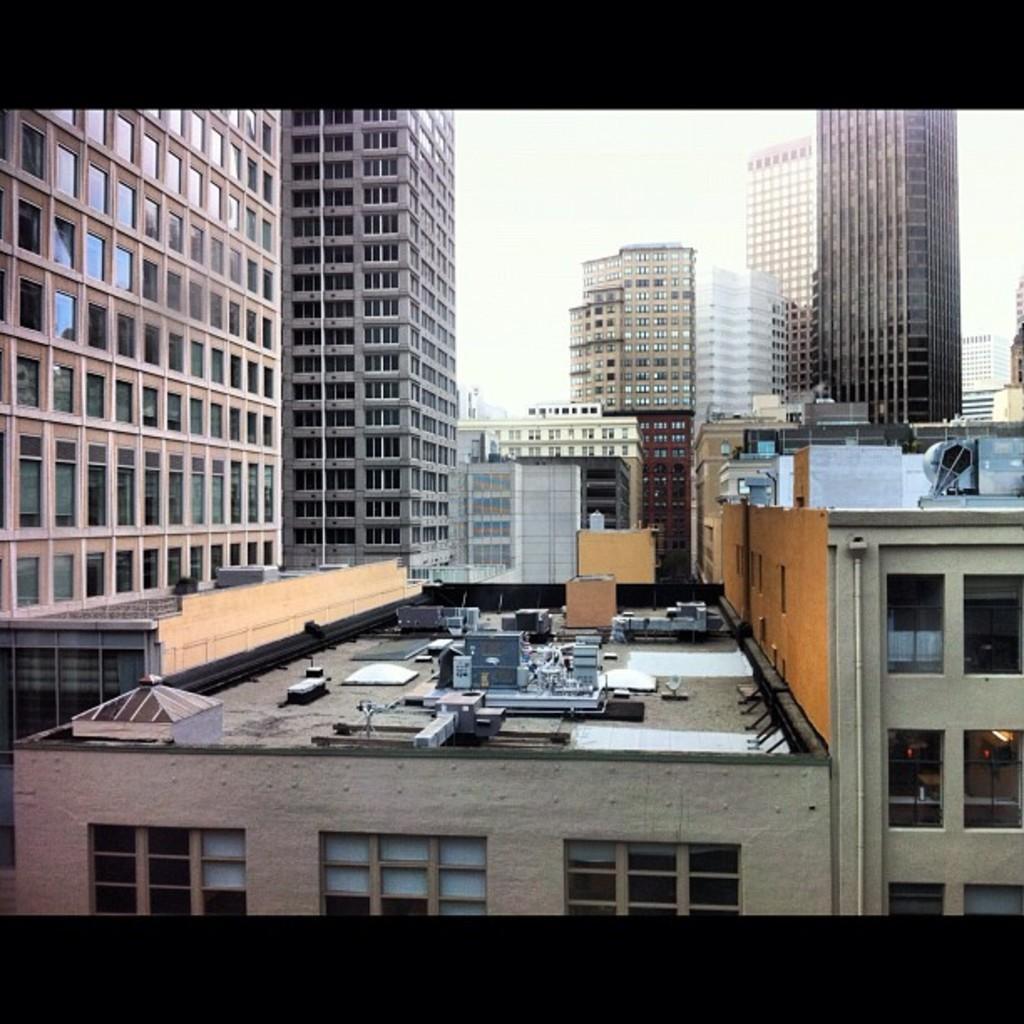How would you summarize this image in a sentence or two? We can see there are some buildings in the middle of this image, and there is a sky at the top of this image. 